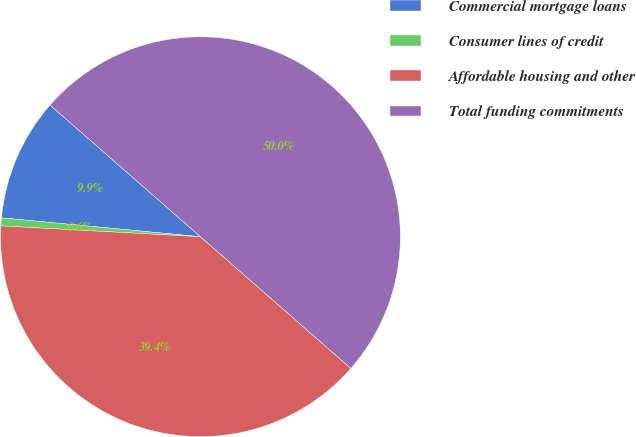<chart> <loc_0><loc_0><loc_500><loc_500><pie_chart><fcel>Commercial mortgage loans<fcel>Consumer lines of credit<fcel>Affordable housing and other<fcel>Total funding commitments<nl><fcel>9.94%<fcel>0.64%<fcel>39.42%<fcel>50.0%<nl></chart> 